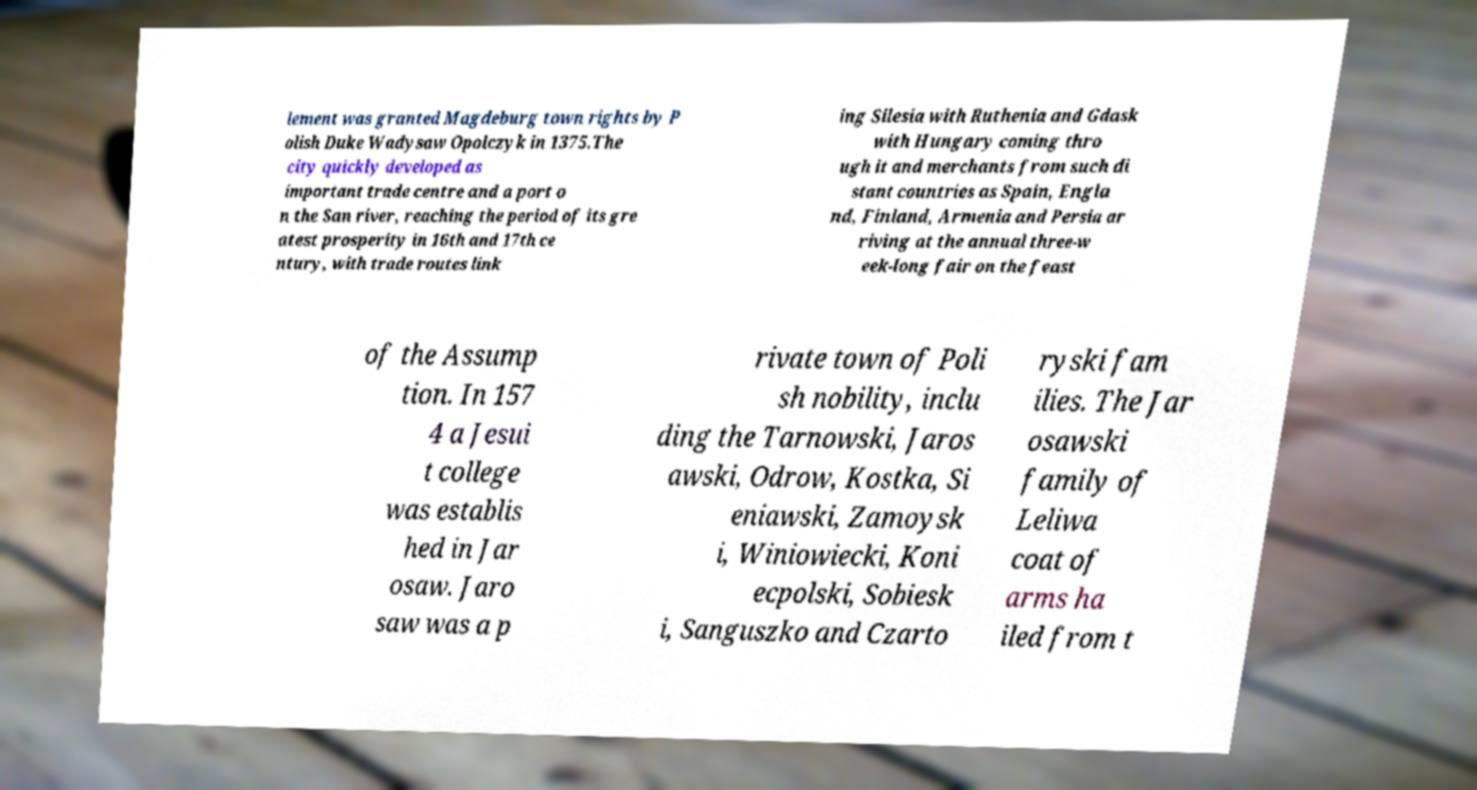Please read and relay the text visible in this image. What does it say? lement was granted Magdeburg town rights by P olish Duke Wadysaw Opolczyk in 1375.The city quickly developed as important trade centre and a port o n the San river, reaching the period of its gre atest prosperity in 16th and 17th ce ntury, with trade routes link ing Silesia with Ruthenia and Gdask with Hungary coming thro ugh it and merchants from such di stant countries as Spain, Engla nd, Finland, Armenia and Persia ar riving at the annual three-w eek-long fair on the feast of the Assump tion. In 157 4 a Jesui t college was establis hed in Jar osaw. Jaro saw was a p rivate town of Poli sh nobility, inclu ding the Tarnowski, Jaros awski, Odrow, Kostka, Si eniawski, Zamoysk i, Winiowiecki, Koni ecpolski, Sobiesk i, Sanguszko and Czarto ryski fam ilies. The Jar osawski family of Leliwa coat of arms ha iled from t 